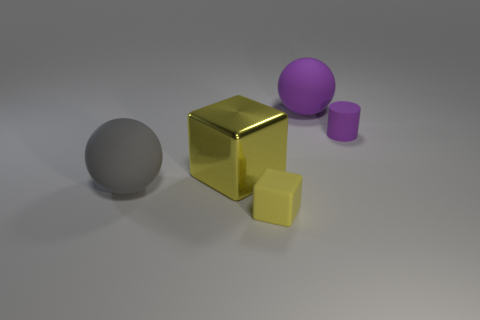There is a large object that is the same color as the tiny matte block; what is its material?
Offer a terse response. Metal. The large yellow object that is in front of the sphere that is behind the large yellow cube is made of what material?
Your answer should be very brief. Metal. Is the number of big gray spheres greater than the number of objects?
Your answer should be very brief. No. Does the metallic thing have the same color as the matte cube?
Give a very brief answer. Yes. There is a yellow cube that is the same size as the purple cylinder; what is its material?
Give a very brief answer. Rubber. Is the small purple cylinder made of the same material as the big block?
Make the answer very short. No. What number of balls have the same material as the big gray object?
Make the answer very short. 1. What number of objects are yellow objects that are in front of the gray sphere or tiny objects that are in front of the big gray matte thing?
Offer a very short reply. 1. Is the number of big yellow objects left of the rubber block greater than the number of purple matte objects that are behind the gray matte object?
Offer a terse response. No. The large matte ball that is in front of the small purple matte object is what color?
Offer a very short reply. Gray. 